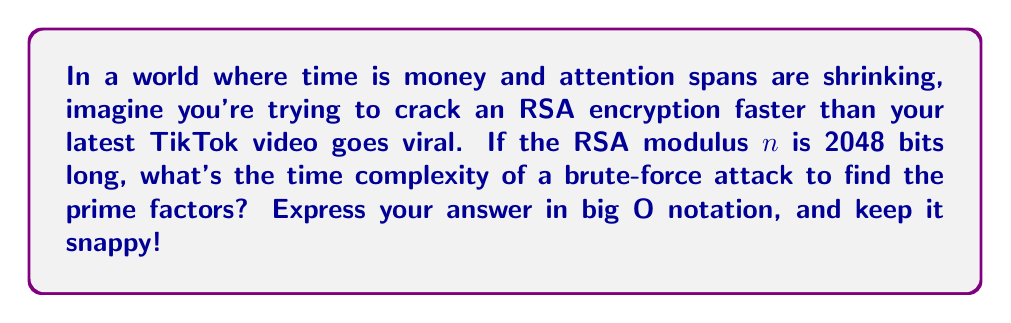Show me your answer to this math problem. Let's break this down in a way that's as quick and attention-grabbing as your social media content:

1) RSA security relies on the difficulty of factoring large numbers. The modulus $n$ is the product of two prime numbers $p$ and $q$.

2) In a brute-force attack, we'd try dividing $n$ by every number up to $\sqrt{n}$.

3) The number of operations is proportional to $\sqrt{n}$.

4) Since $n$ is 2048 bits long, $n \approx 2^{2048}$.

5) Therefore, $\sqrt{n} \approx 2^{1024}$.

6) In big O notation, we express this as $O(2^{1024})$.

7) This is equivalent to $O(2^{\frac{k}{2}})$, where $k$ is the number of bits in $n$.

That's it! Short, sweet, and to the point – just like your viral content.
Answer: $O(2^{\frac{k}{2}})$ 